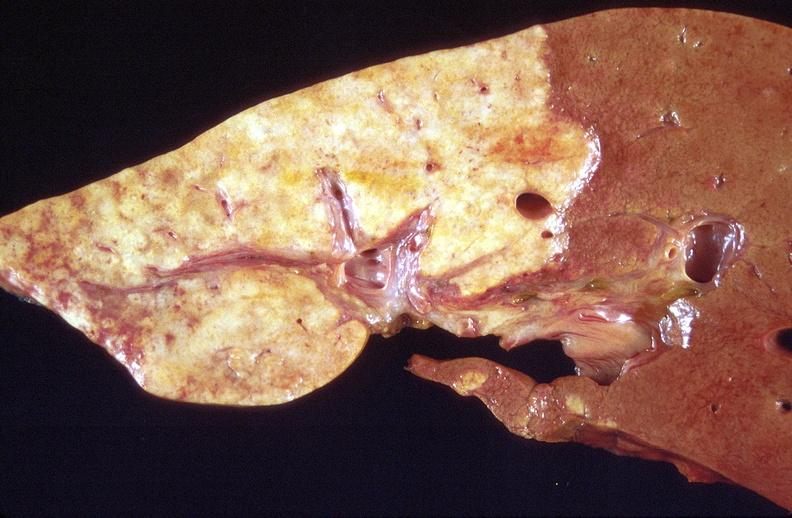does this image show cholangiocarcinoma?
Answer the question using a single word or phrase. Yes 